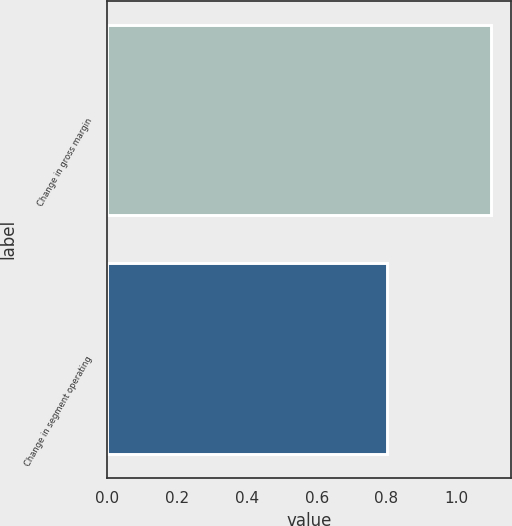<chart> <loc_0><loc_0><loc_500><loc_500><bar_chart><fcel>Change in gross margin<fcel>Change in segment operating<nl><fcel>1.1<fcel>0.8<nl></chart> 